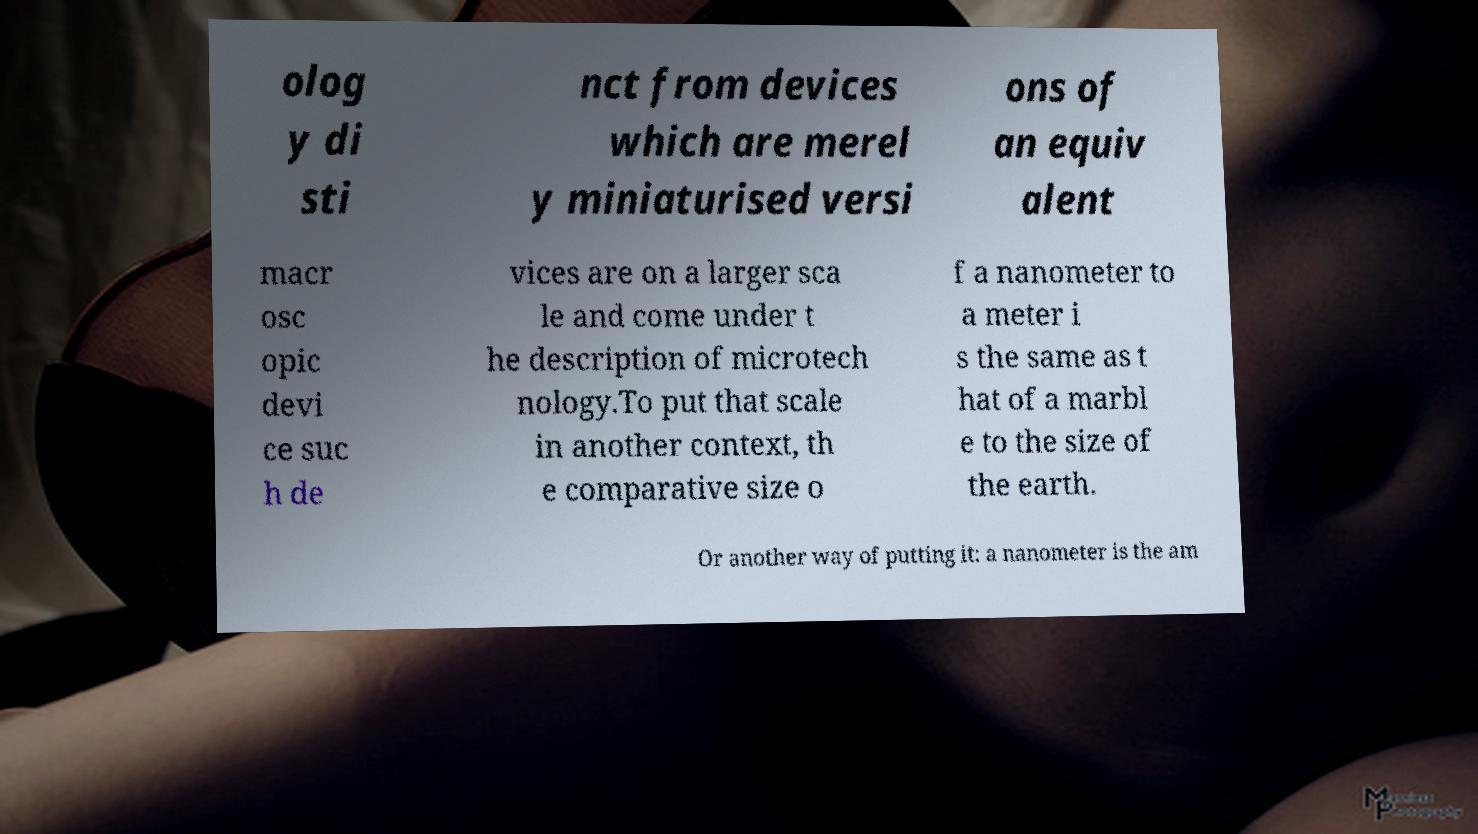For documentation purposes, I need the text within this image transcribed. Could you provide that? olog y di sti nct from devices which are merel y miniaturised versi ons of an equiv alent macr osc opic devi ce suc h de vices are on a larger sca le and come under t he description of microtech nology.To put that scale in another context, th e comparative size o f a nanometer to a meter i s the same as t hat of a marbl e to the size of the earth. Or another way of putting it: a nanometer is the am 